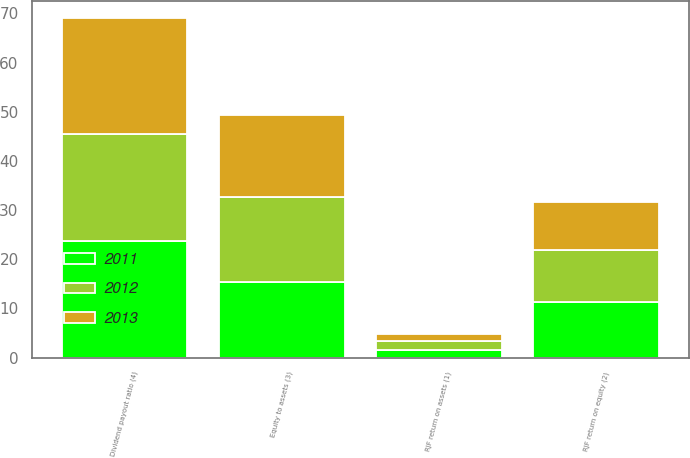Convert chart to OTSL. <chart><loc_0><loc_0><loc_500><loc_500><stacked_bar_chart><ecel><fcel>RJF return on assets (1)<fcel>RJF return on equity (2)<fcel>Equity to assets (3)<fcel>Dividend payout ratio (4)<nl><fcel>2012<fcel>1.7<fcel>10.6<fcel>17.3<fcel>21.7<nl><fcel>2013<fcel>1.5<fcel>9.7<fcel>16.8<fcel>23.6<nl><fcel>2011<fcel>1.6<fcel>11.3<fcel>15.3<fcel>23.7<nl></chart> 